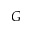Convert formula to latex. <formula><loc_0><loc_0><loc_500><loc_500>G</formula> 